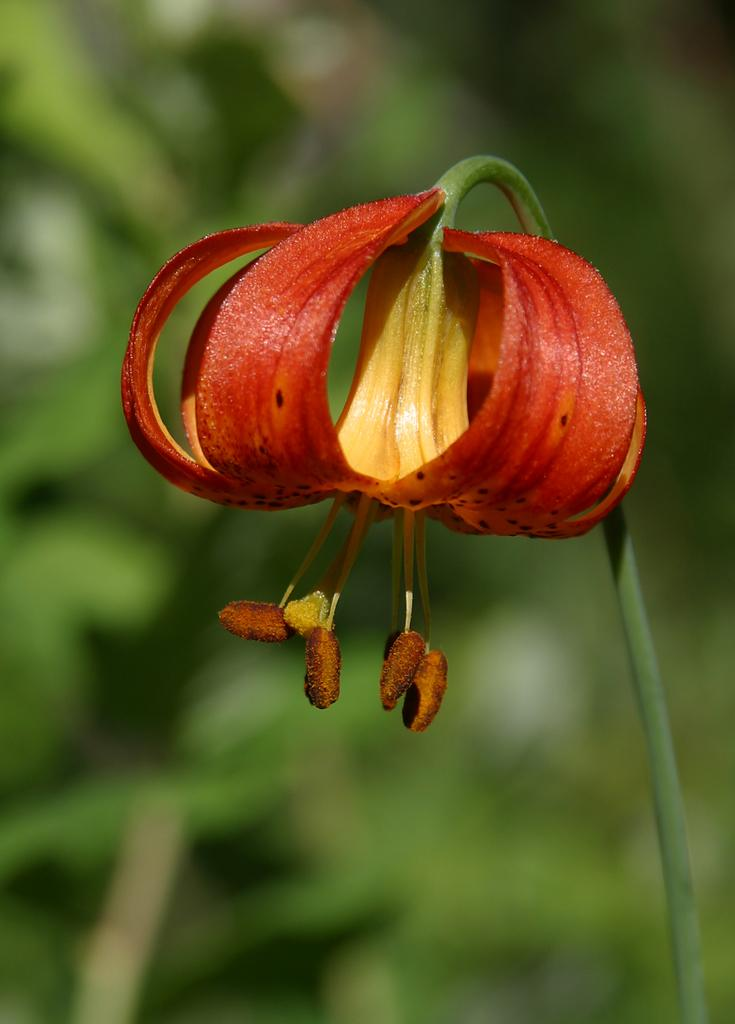What is the main subject of the image? There is a flower in the image. Can you describe the color of the flower? The flower is orange in color. What items are on the list that the father is holding in the image? There is no list or father present in the image; it only features a flower. 